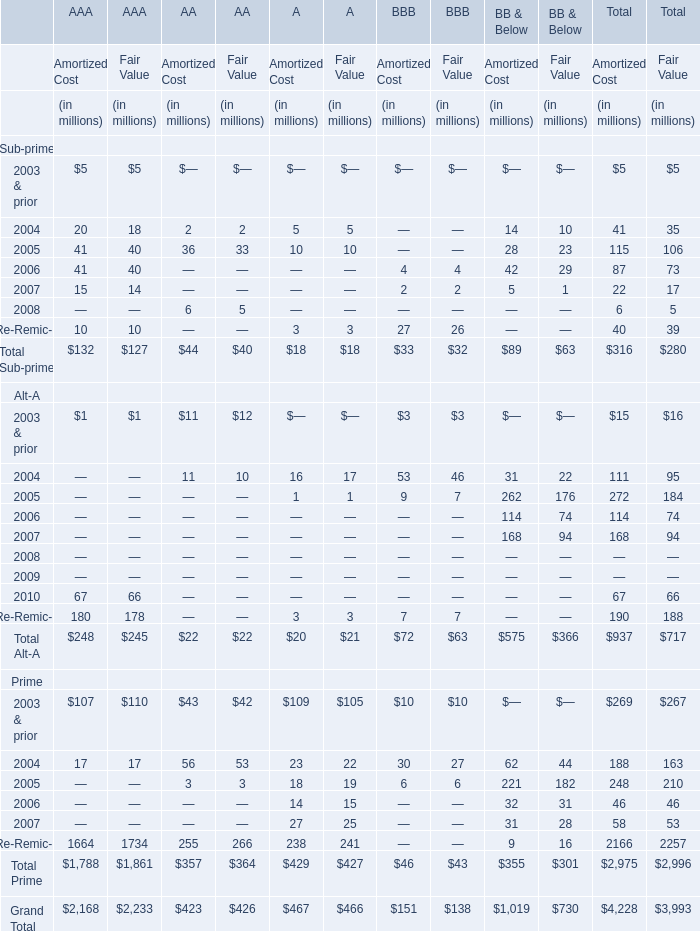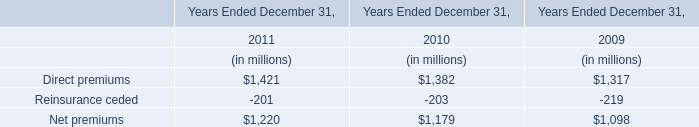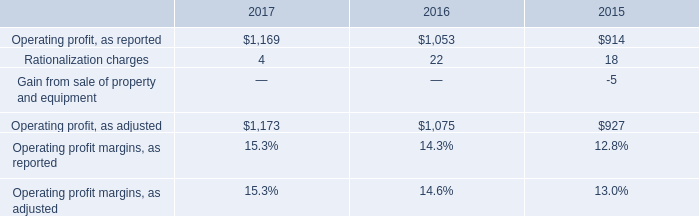What's the total amount of the Sub-prime of AAA with Amortized Cost in the year where Sub-prime of Total with Amortized Cost is greater than 100? (in dollars in millions) 
Answer: 41. what was the percentage change in the gross profit margins from 2016 to 2017 
Computations: ((34.2 - 33.4) / 33.4)
Answer: 0.02395. 